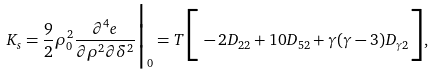Convert formula to latex. <formula><loc_0><loc_0><loc_500><loc_500>K _ { s } = \frac { 9 } { 2 } \rho _ { 0 } ^ { 2 } \frac { \partial ^ { 4 } e } { \partial \rho ^ { 2 } \partial \delta ^ { 2 } } \Big | _ { 0 } = T \Big [ - 2 D _ { 2 2 } + 1 0 D _ { 5 2 } + \gamma ( \gamma - 3 ) D _ { \gamma 2 } \Big ] ,</formula> 